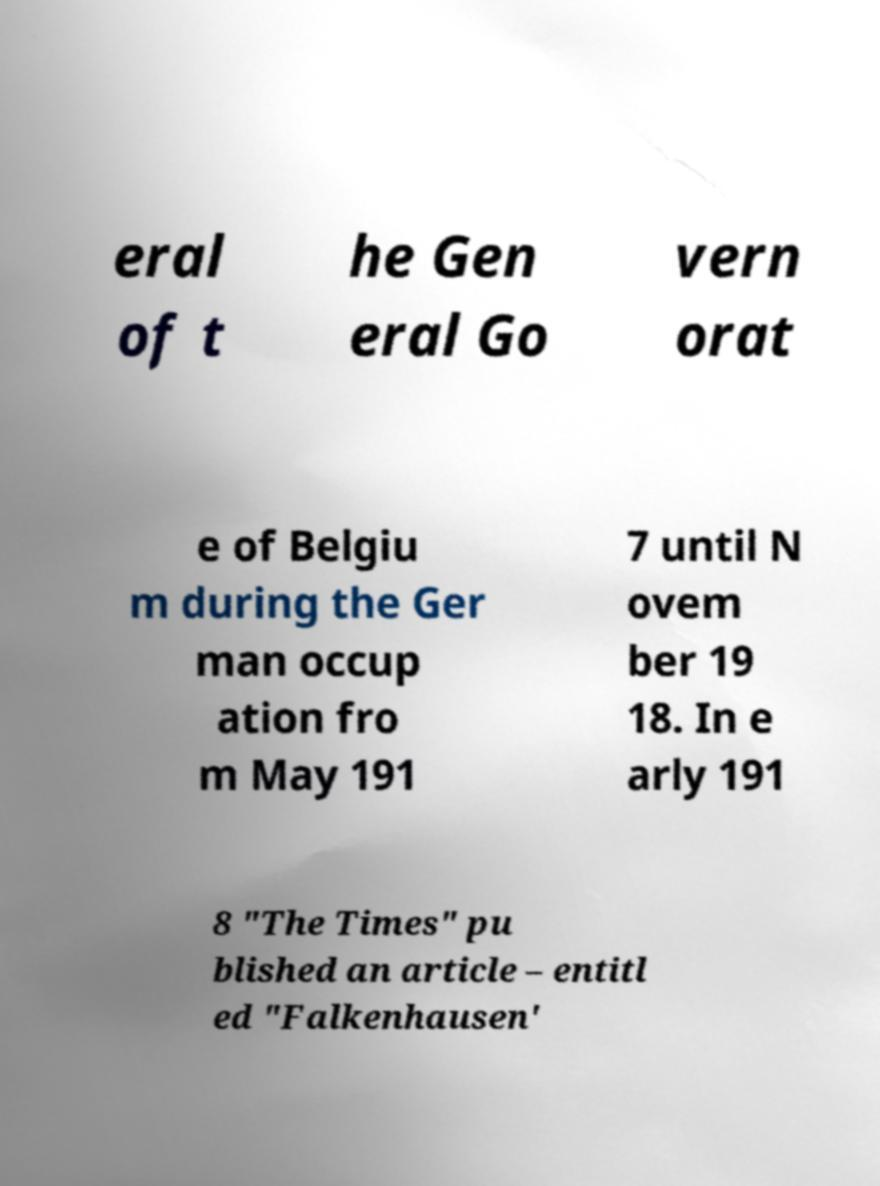For documentation purposes, I need the text within this image transcribed. Could you provide that? eral of t he Gen eral Go vern orat e of Belgiu m during the Ger man occup ation fro m May 191 7 until N ovem ber 19 18. In e arly 191 8 "The Times" pu blished an article – entitl ed "Falkenhausen' 